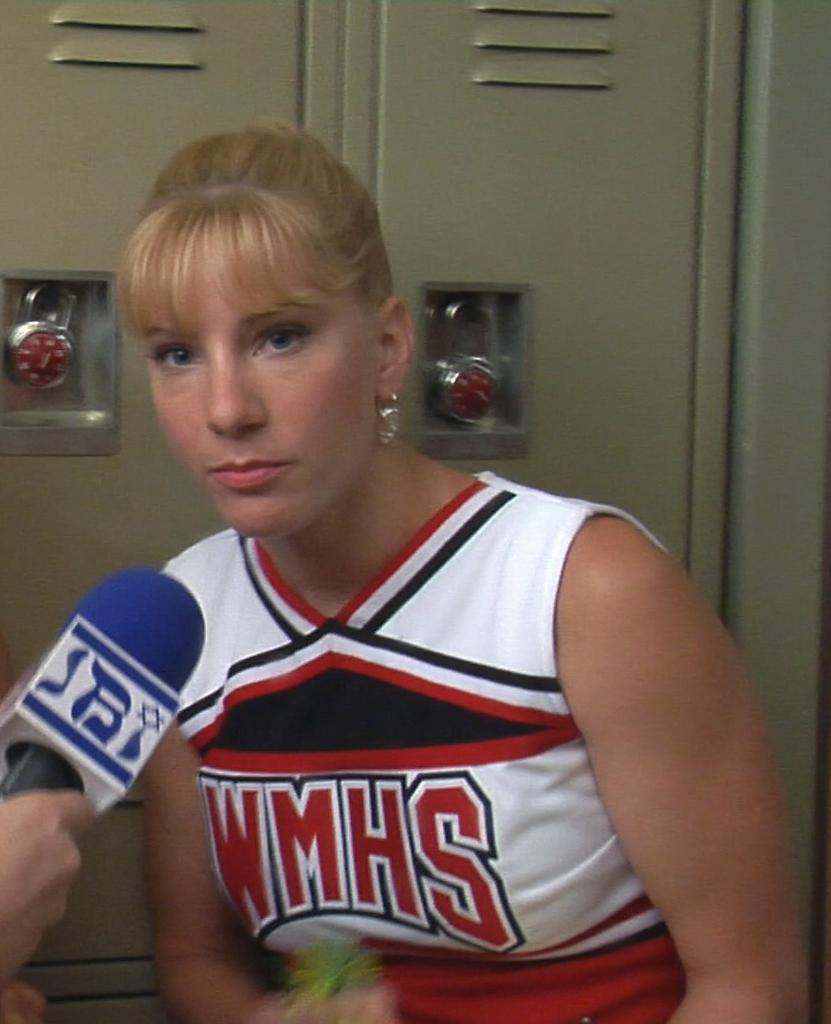<image>
Summarize the visual content of the image. A WMHS cheerleader is speaking into a microphone. 